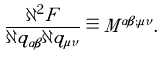<formula> <loc_0><loc_0><loc_500><loc_500>\frac { \partial ^ { 2 } F } { \partial q _ { \alpha \beta } \partial q _ { \mu \nu } } \equiv M ^ { \alpha \beta ; \mu \nu } .</formula> 